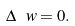<formula> <loc_0><loc_0><loc_500><loc_500>\Delta \ w = 0 .</formula> 